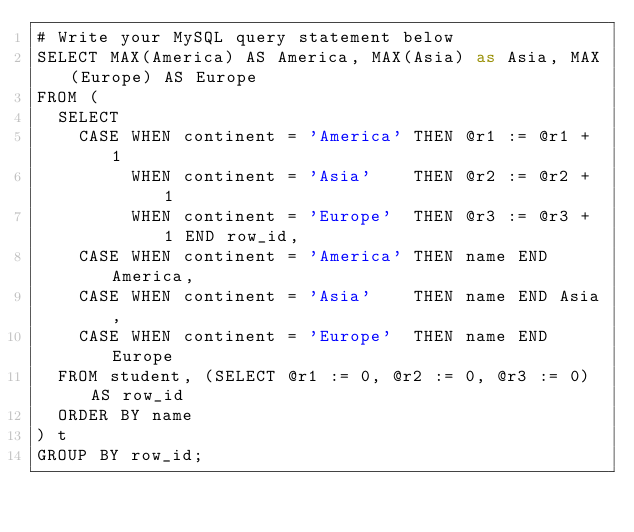<code> <loc_0><loc_0><loc_500><loc_500><_SQL_># Write your MySQL query statement below
SELECT MAX(America) AS America, MAX(Asia) as Asia, MAX(Europe) AS Europe
FROM (
  SELECT 
    CASE WHEN continent = 'America' THEN @r1 := @r1 + 1
         WHEN continent = 'Asia'    THEN @r2 := @r2 + 1
         WHEN continent = 'Europe'  THEN @r3 := @r3 + 1 END row_id,
    CASE WHEN continent = 'America' THEN name END America,
    CASE WHEN continent = 'Asia'    THEN name END Asia,
    CASE WHEN continent = 'Europe'  THEN name END Europe
  FROM student, (SELECT @r1 := 0, @r2 := 0, @r3 := 0) AS row_id
  ORDER BY name
) t
GROUP BY row_id;
</code> 